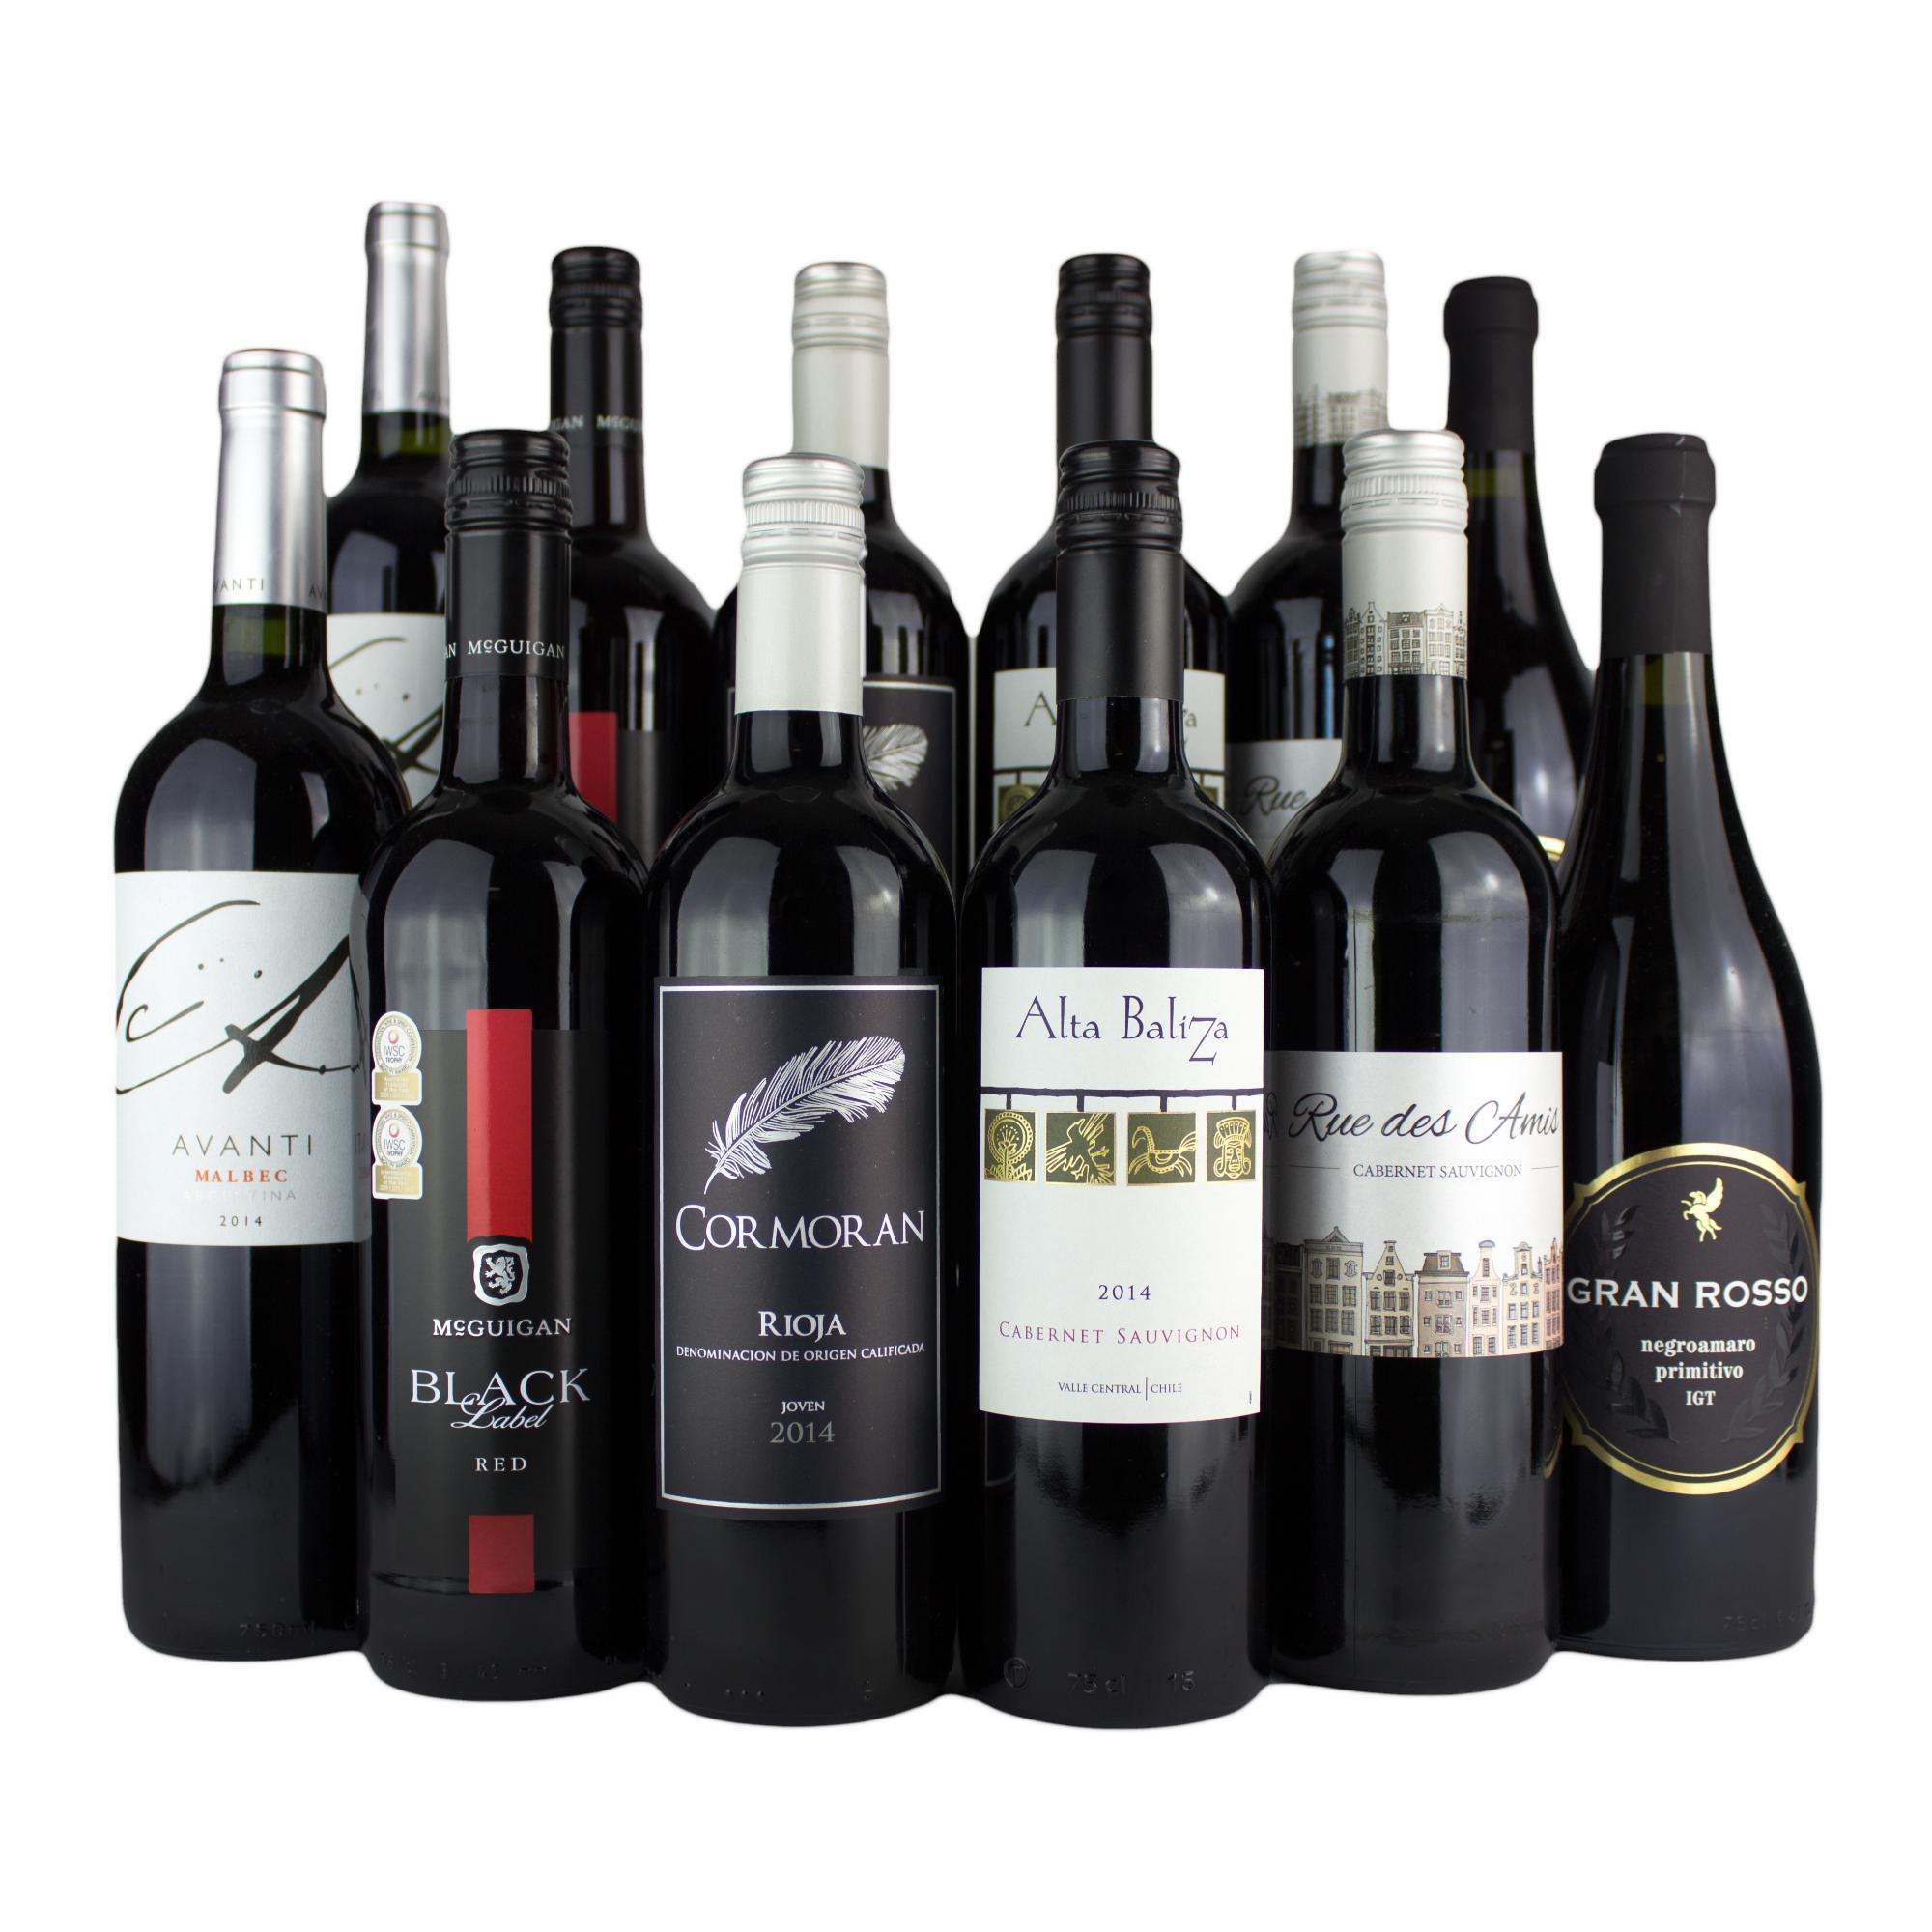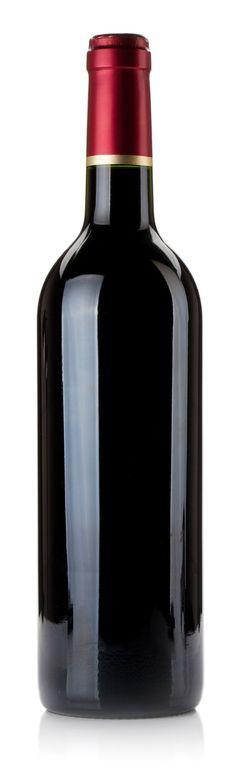The first image is the image on the left, the second image is the image on the right. Examine the images to the left and right. Is the description "A large variety of wines is paired with a single bottle with colored top." accurate? Answer yes or no. Yes. 